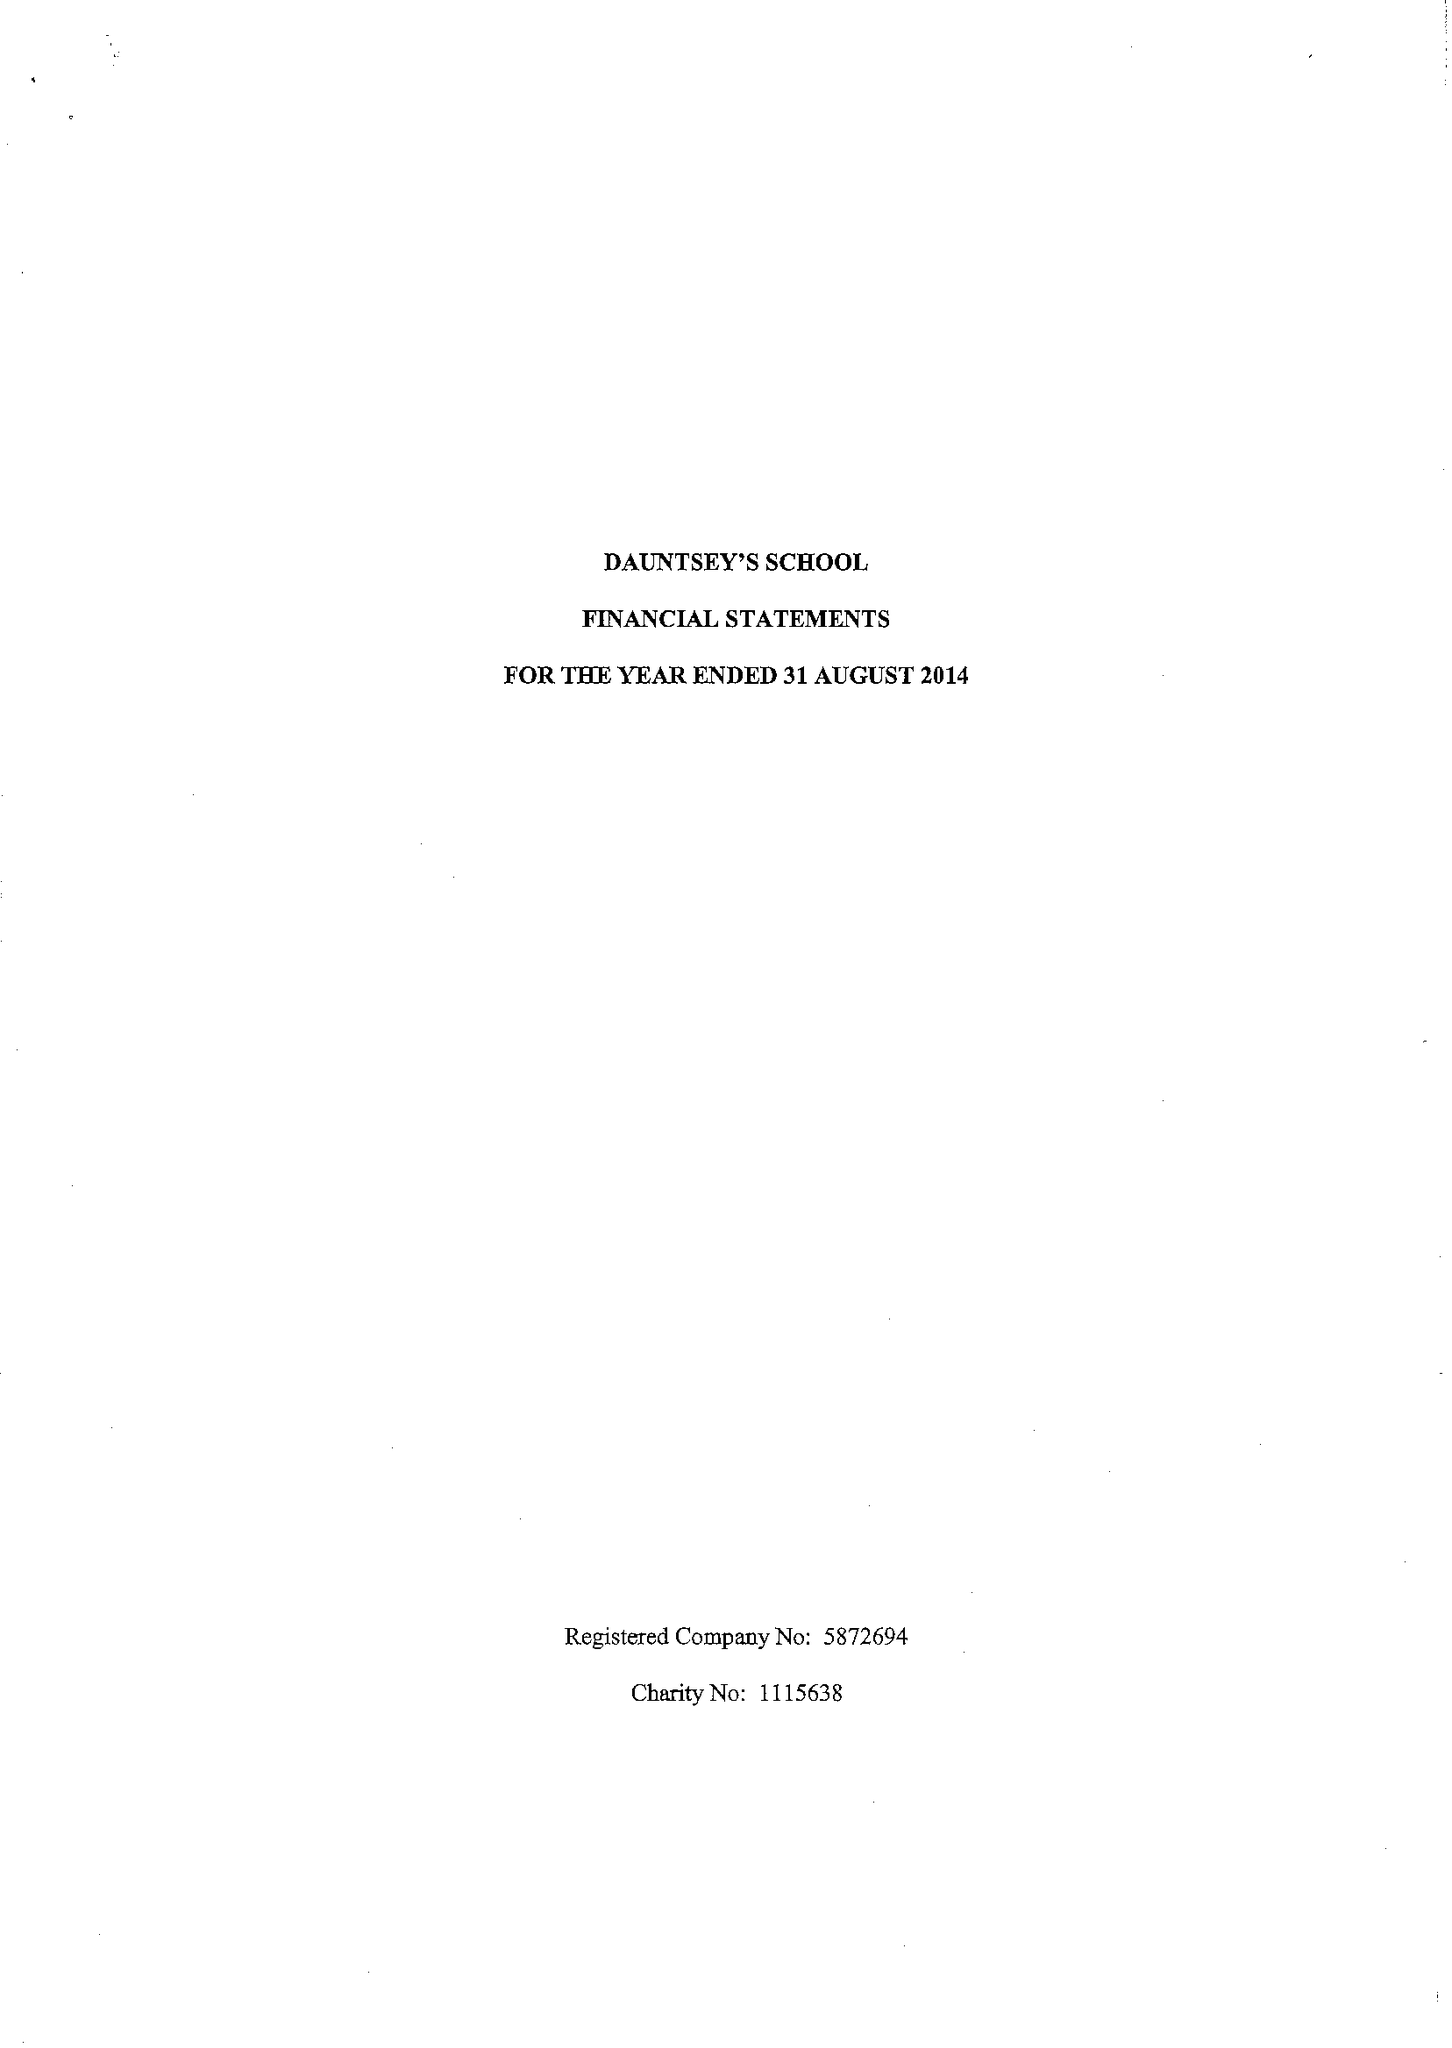What is the value for the spending_annually_in_british_pounds?
Answer the question using a single word or phrase. 15368405.00 